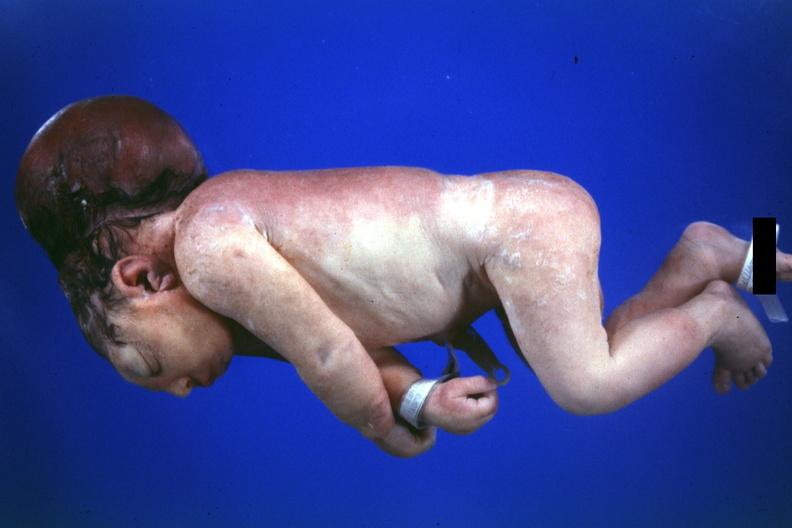what lived one day?
Answer the question using a single word or phrase. No chromosomal defects 